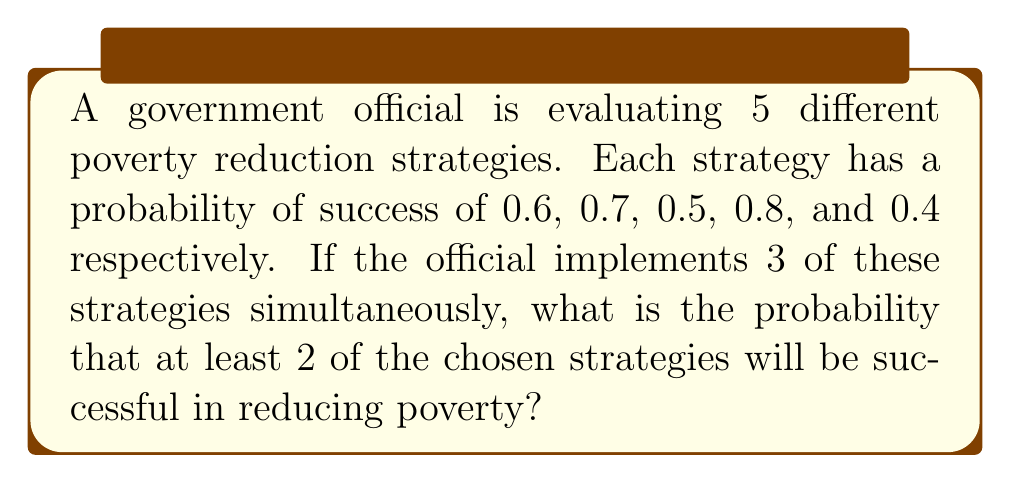Could you help me with this problem? To solve this problem, we need to use the concept of combinations and probability.

Step 1: Calculate the number of ways to choose 3 strategies out of 5.
This can be done using the combination formula:
$${5 \choose 3} = \frac{5!}{3!(5-3)!} = \frac{5!}{3!2!} = 10$$

Step 2: List all possible combinations of 3 strategies:
(1,2,3), (1,2,4), (1,2,5), (1,3,4), (1,3,5), (1,4,5), (2,3,4), (2,3,5), (2,4,5), (3,4,5)

Step 3: For each combination, calculate the probability of at least 2 successes.
We can do this by subtracting the probability of 0 or 1 success from 1.

For example, for combination (1,2,3):
$$P(\text{at least 2 successes}) = 1 - [P(0 \text{ successes}) + P(1 \text{ success})]$$
$$= 1 - [(0.4 \cdot 0.3 \cdot 0.5) + (0.6 \cdot 0.3 \cdot 0.5 + 0.4 \cdot 0.7 \cdot 0.5 + 0.4 \cdot 0.3 \cdot 0.5)]$$
$$= 1 - [0.06 + 0.31] = 0.63$$

Step 4: Calculate this probability for all 10 combinations:
(1,2,3): 0.63
(1,2,4): 0.804
(1,2,5): 0.538
(1,3,4): 0.764
(1,3,5): 0.498
(1,4,5): 0.656
(2,3,4): 0.818
(2,3,5): 0.552
(2,4,5): 0.71
(3,4,5): 0.67

Step 5: Calculate the average of these probabilities:
$$(0.63 + 0.804 + 0.538 + 0.764 + 0.498 + 0.656 + 0.818 + 0.552 + 0.71 + 0.67) \div 10 = 0.664$$

Therefore, the probability that at least 2 of the chosen strategies will be successful is approximately 0.664 or 66.4%.
Answer: 0.664 or 66.4% 